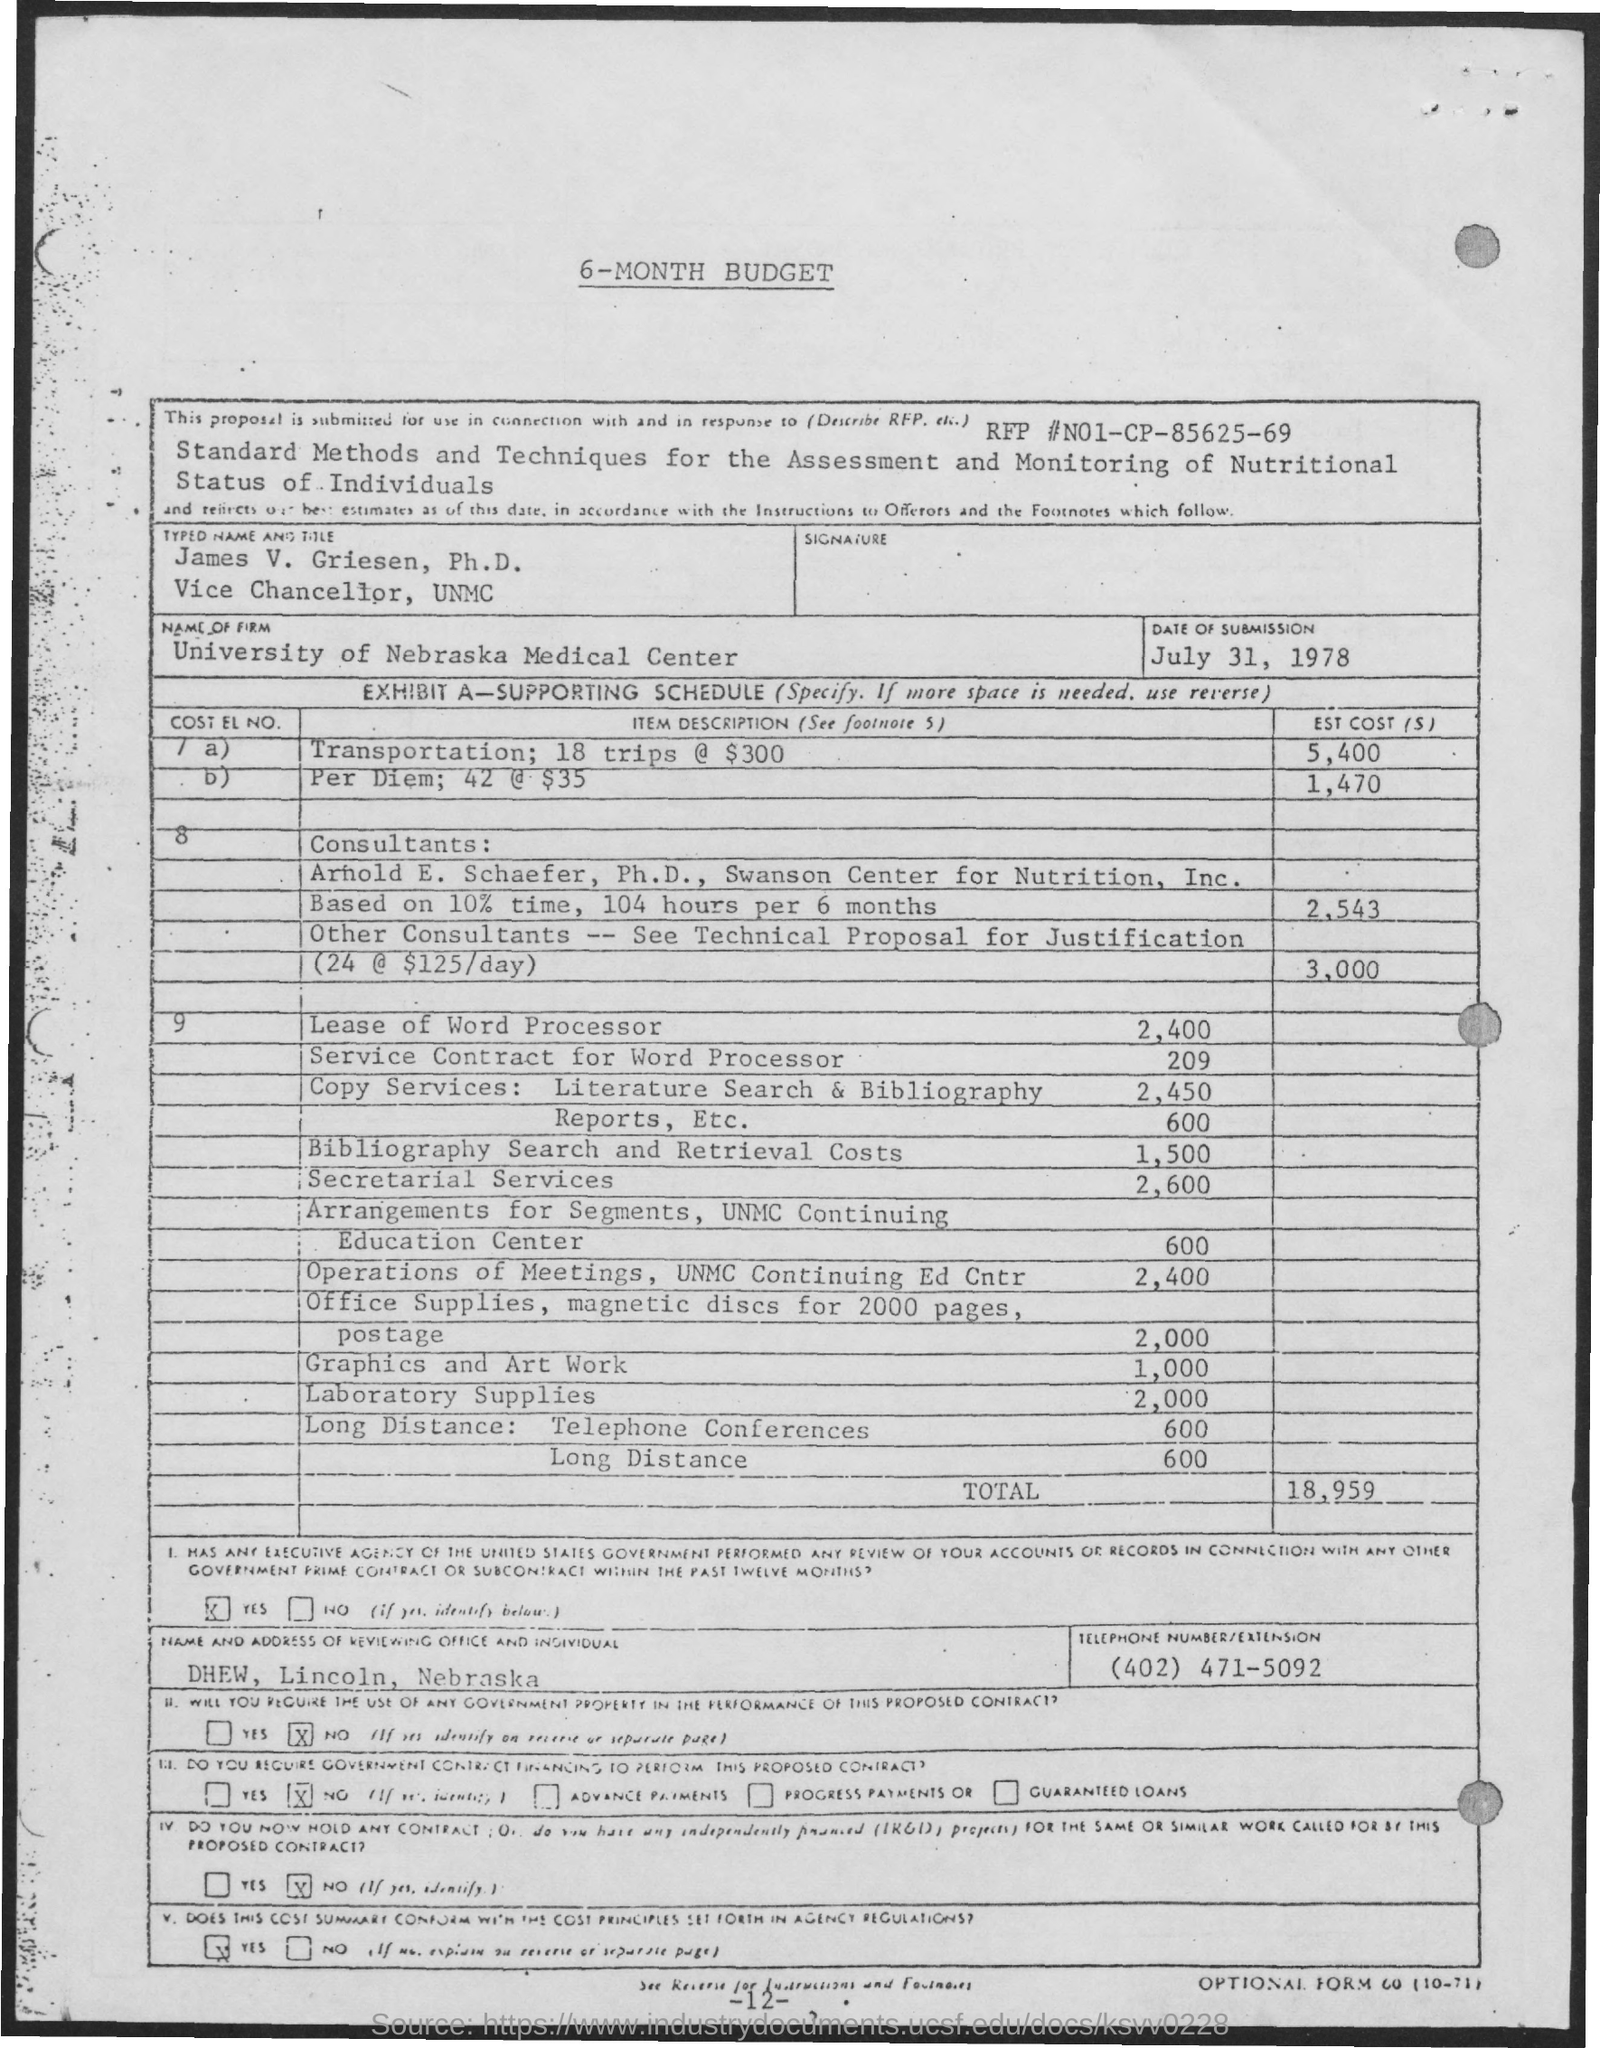Point out several critical features in this image. The total estimated budget is 18,959. The name given in the form is "James V. Griesen, Ph.D. The date of submission mentioned in the form is July 31, 1978. The RFP number mentioned in the form is N01-CP-85625-69. The firm named in the form is "UNIVERSITY OF NEBRASKA MEDICAL CENTER. 